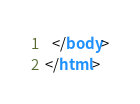Convert code to text. <code><loc_0><loc_0><loc_500><loc_500><_HTML_>  </body>
</html>
</code> 